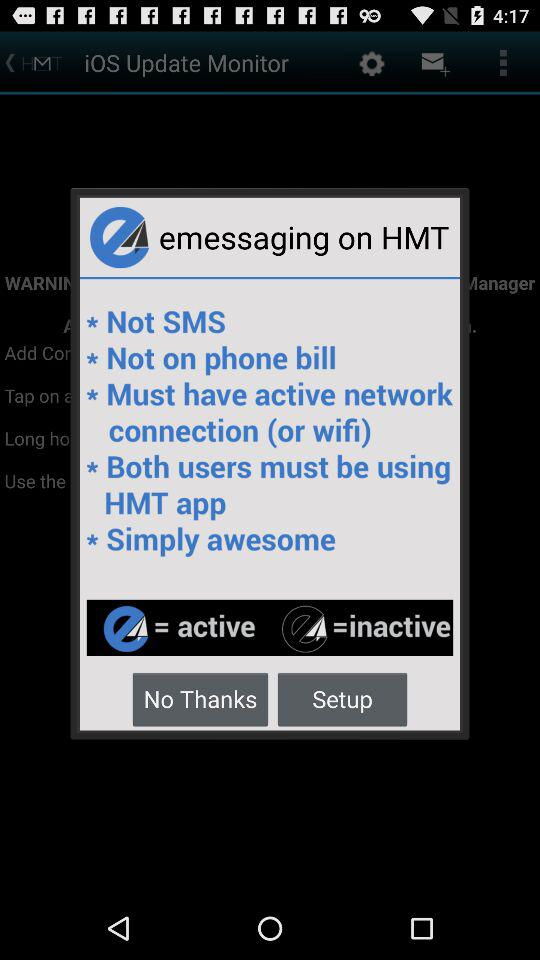What is the application name? The application name is "iOS Update Monitor". 